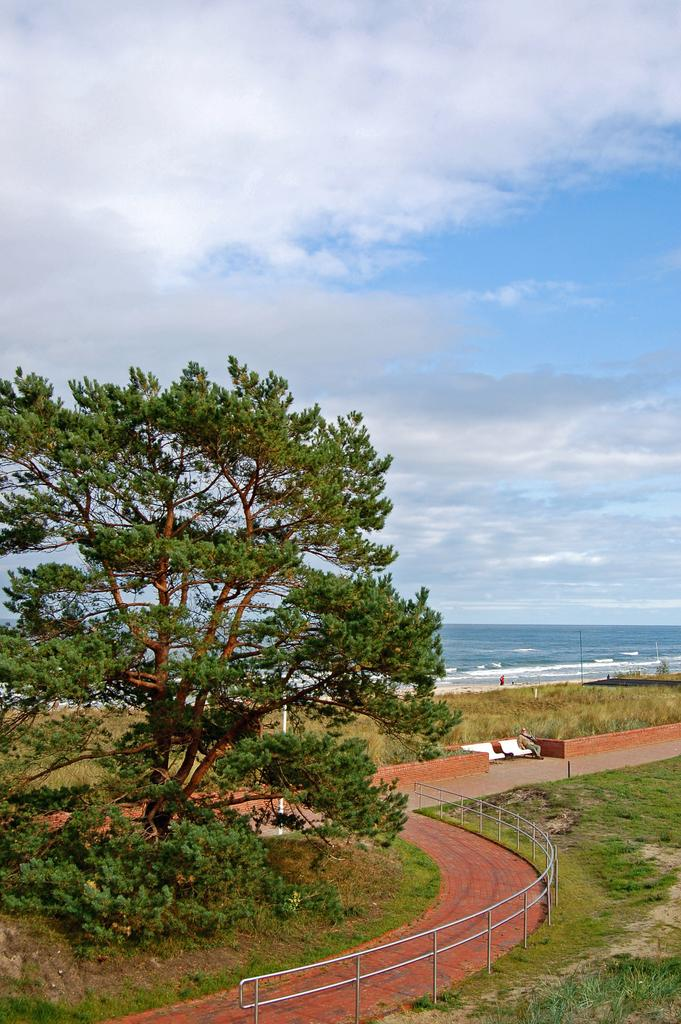What type of vegetation can be seen in the image? There are trees in the image. What type of barrier is present in the image? There is fencing in the image. What type of seating is visible in the image? There are chairs in the image. What is the condition of the ground in the image? Dry grass is visible in the image. What natural element is present in the image? There is water in the image. How would you describe the color of the sky in the image? The sky is a combination of white and blue colors. What type of quilt is being used to cover the sea in the image? There is no sea or quilt present in the image. What type of relation can be seen between the chairs and the trees in the image? There is no relation between the chairs and the trees mentioned in the image; they are separate subjects. 